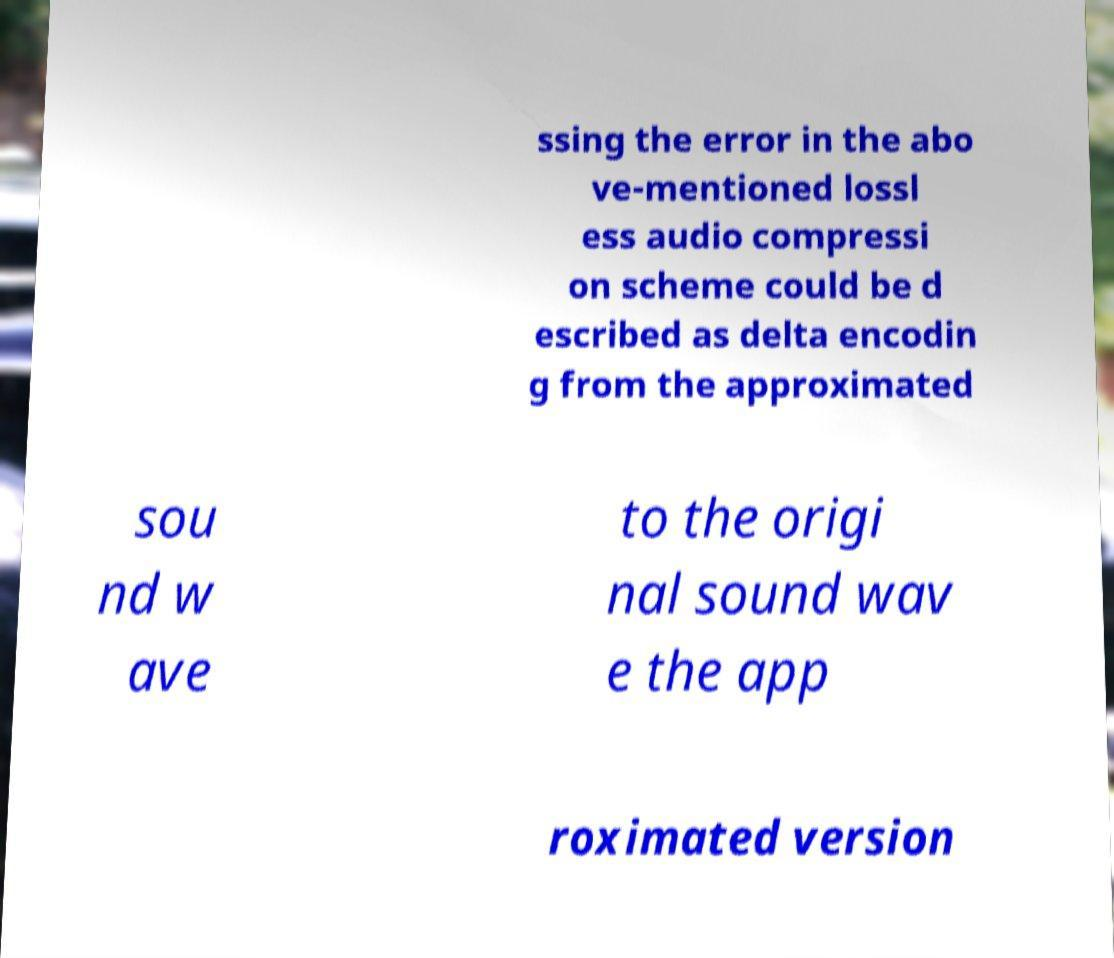Can you read and provide the text displayed in the image?This photo seems to have some interesting text. Can you extract and type it out for me? ssing the error in the abo ve-mentioned lossl ess audio compressi on scheme could be d escribed as delta encodin g from the approximated sou nd w ave to the origi nal sound wav e the app roximated version 